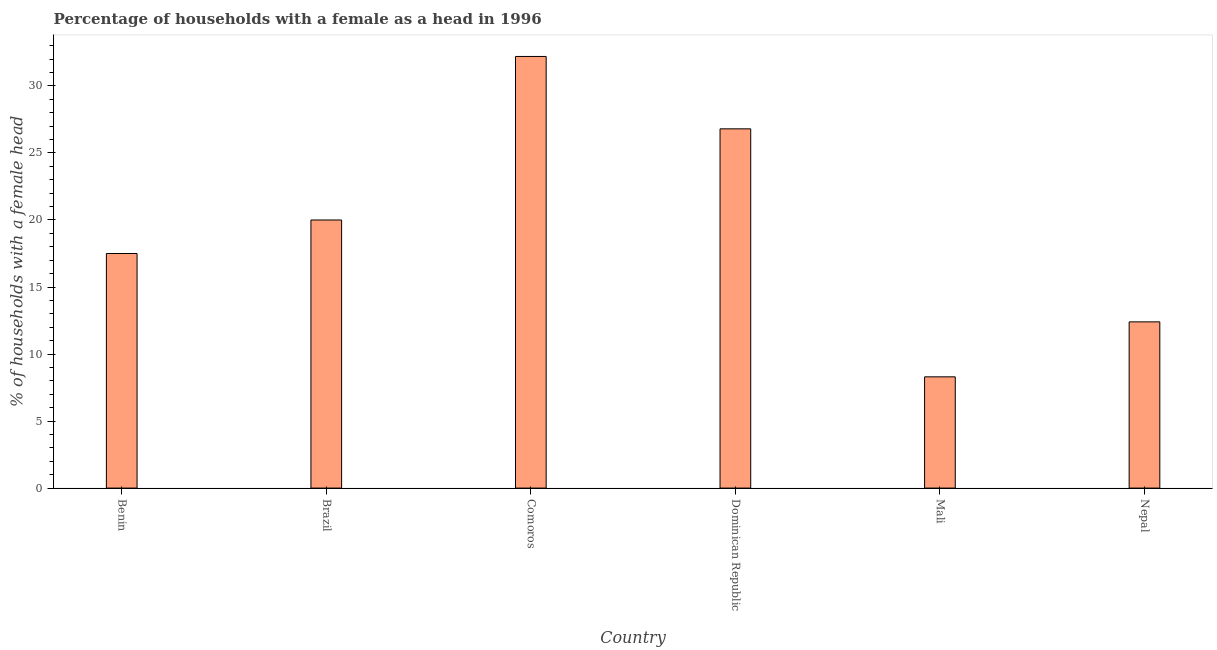Does the graph contain any zero values?
Offer a terse response. No. Does the graph contain grids?
Offer a very short reply. No. What is the title of the graph?
Offer a terse response. Percentage of households with a female as a head in 1996. What is the label or title of the X-axis?
Your answer should be compact. Country. What is the label or title of the Y-axis?
Your answer should be compact. % of households with a female head. What is the number of female supervised households in Benin?
Your response must be concise. 17.5. Across all countries, what is the maximum number of female supervised households?
Ensure brevity in your answer.  32.2. Across all countries, what is the minimum number of female supervised households?
Provide a short and direct response. 8.3. In which country was the number of female supervised households maximum?
Your answer should be compact. Comoros. In which country was the number of female supervised households minimum?
Give a very brief answer. Mali. What is the sum of the number of female supervised households?
Ensure brevity in your answer.  117.2. What is the average number of female supervised households per country?
Make the answer very short. 19.53. What is the median number of female supervised households?
Offer a terse response. 18.75. What is the ratio of the number of female supervised households in Benin to that in Mali?
Offer a very short reply. 2.11. What is the difference between the highest and the second highest number of female supervised households?
Provide a short and direct response. 5.4. Is the sum of the number of female supervised households in Benin and Nepal greater than the maximum number of female supervised households across all countries?
Give a very brief answer. No. What is the difference between the highest and the lowest number of female supervised households?
Your answer should be compact. 23.9. In how many countries, is the number of female supervised households greater than the average number of female supervised households taken over all countries?
Provide a short and direct response. 3. Are all the bars in the graph horizontal?
Keep it short and to the point. No. How many countries are there in the graph?
Give a very brief answer. 6. What is the difference between two consecutive major ticks on the Y-axis?
Ensure brevity in your answer.  5. Are the values on the major ticks of Y-axis written in scientific E-notation?
Ensure brevity in your answer.  No. What is the % of households with a female head in Benin?
Offer a terse response. 17.5. What is the % of households with a female head of Comoros?
Keep it short and to the point. 32.2. What is the % of households with a female head of Dominican Republic?
Provide a succinct answer. 26.8. What is the % of households with a female head of Mali?
Offer a very short reply. 8.3. What is the % of households with a female head in Nepal?
Offer a terse response. 12.4. What is the difference between the % of households with a female head in Benin and Brazil?
Make the answer very short. -2.5. What is the difference between the % of households with a female head in Benin and Comoros?
Keep it short and to the point. -14.7. What is the difference between the % of households with a female head in Benin and Mali?
Ensure brevity in your answer.  9.2. What is the difference between the % of households with a female head in Brazil and Comoros?
Make the answer very short. -12.2. What is the difference between the % of households with a female head in Comoros and Mali?
Make the answer very short. 23.9. What is the difference between the % of households with a female head in Comoros and Nepal?
Your response must be concise. 19.8. What is the difference between the % of households with a female head in Mali and Nepal?
Make the answer very short. -4.1. What is the ratio of the % of households with a female head in Benin to that in Comoros?
Your answer should be very brief. 0.54. What is the ratio of the % of households with a female head in Benin to that in Dominican Republic?
Your answer should be compact. 0.65. What is the ratio of the % of households with a female head in Benin to that in Mali?
Make the answer very short. 2.11. What is the ratio of the % of households with a female head in Benin to that in Nepal?
Offer a very short reply. 1.41. What is the ratio of the % of households with a female head in Brazil to that in Comoros?
Your answer should be very brief. 0.62. What is the ratio of the % of households with a female head in Brazil to that in Dominican Republic?
Your answer should be compact. 0.75. What is the ratio of the % of households with a female head in Brazil to that in Mali?
Provide a succinct answer. 2.41. What is the ratio of the % of households with a female head in Brazil to that in Nepal?
Keep it short and to the point. 1.61. What is the ratio of the % of households with a female head in Comoros to that in Dominican Republic?
Your response must be concise. 1.2. What is the ratio of the % of households with a female head in Comoros to that in Mali?
Provide a succinct answer. 3.88. What is the ratio of the % of households with a female head in Comoros to that in Nepal?
Offer a very short reply. 2.6. What is the ratio of the % of households with a female head in Dominican Republic to that in Mali?
Keep it short and to the point. 3.23. What is the ratio of the % of households with a female head in Dominican Republic to that in Nepal?
Your answer should be very brief. 2.16. What is the ratio of the % of households with a female head in Mali to that in Nepal?
Provide a succinct answer. 0.67. 